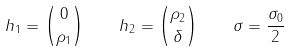<formula> <loc_0><loc_0><loc_500><loc_500>h _ { 1 } = { 0 \choose \rho _ { 1 } } \quad h _ { 2 } = { \rho _ { 2 } \choose \delta } \quad \sigma = \frac { \sigma _ { 0 } } 2</formula> 